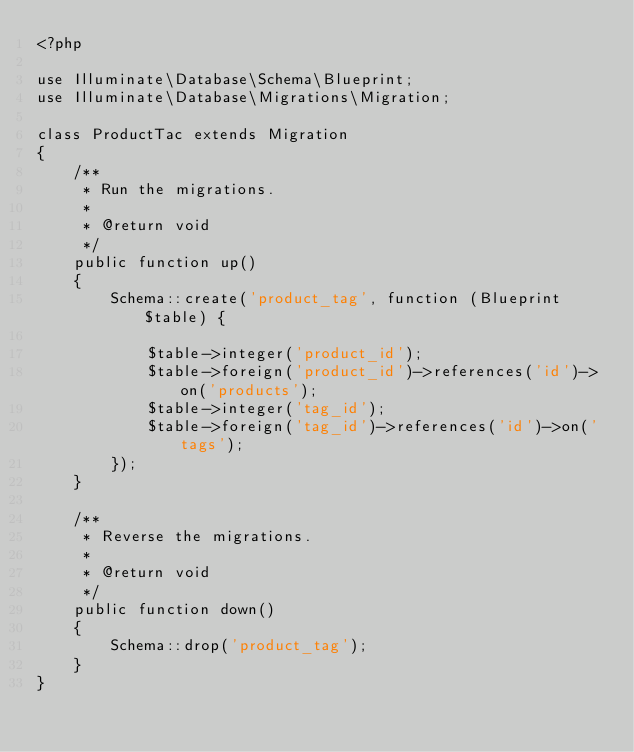Convert code to text. <code><loc_0><loc_0><loc_500><loc_500><_PHP_><?php

use Illuminate\Database\Schema\Blueprint;
use Illuminate\Database\Migrations\Migration;

class ProductTac extends Migration
{
    /**
     * Run the migrations.
     *
     * @return void
     */
    public function up()
    {
        Schema::create('product_tag', function (Blueprint $table) {

            $table->integer('product_id');
            $table->foreign('product_id')->references('id')->on('products');
            $table->integer('tag_id');
            $table->foreign('tag_id')->references('id')->on('tags');
        });
    }

    /**
     * Reverse the migrations.
     *
     * @return void
     */
    public function down()
    {
        Schema::drop('product_tag');
    }
}
</code> 